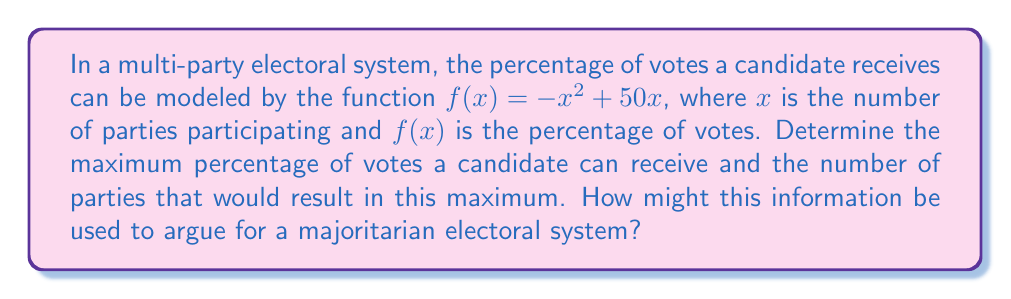What is the answer to this math problem? To find the maximum percentage of votes, we need to find the maximum of the function $f(x) = -x^2 + 50x$. This can be done using derivatives:

1) First, find the derivative of $f(x)$:
   $$f'(x) = -2x + 50$$

2) Set the derivative equal to zero to find the critical point:
   $$-2x + 50 = 0$$
   $$-2x = -50$$
   $$x = 25$$

3) The second derivative is $f''(x) = -2$, which is negative, confirming that $x = 25$ is a maximum.

4) Calculate the maximum percentage by plugging $x = 25$ into the original function:
   $$f(25) = -(25)^2 + 50(25) = -625 + 1250 = 625$$

5) Interpret the results:
   - The maximum percentage of votes occurs when there are 25 parties.
   - The maximum percentage is 625%.

6) Since the maximum percentage exceeds 100%, this model is not realistic for all values of $x$. It's only valid for a smaller range of $x$ where $0 \leq f(x) \leq 100$.

7) To find the realistic maximum within the valid range, we need to solve:
   $$-x^2 + 50x = 100$$
   $$x^2 - 50x + 100 = 0$$
   Using the quadratic formula, we get $x ≈ 2.06$ or $x ≈ 47.94$.

8) The realistic maximum occurs at $x = 2.06$ parties, resulting in a maximum of 100% votes.

This result could be used to argue for a majoritarian system by pointing out that as the number of parties increases beyond 2, the maximum percentage of votes a single candidate can receive decreases, potentially leading to less stable governments and the need for complex coalitions.
Answer: Maximum percentage: 100%. Number of parties for maximum: 2.06 (rounded to 2 in practice). 